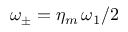<formula> <loc_0><loc_0><loc_500><loc_500>\omega _ { \pm } = \eta _ { m } \, \omega _ { 1 } / 2</formula> 